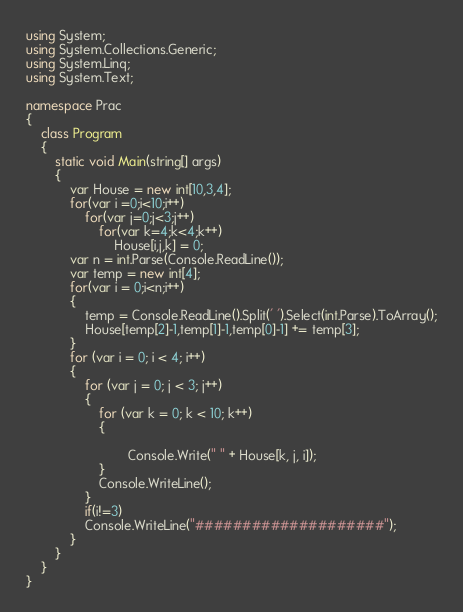Convert code to text. <code><loc_0><loc_0><loc_500><loc_500><_C#_>using System;
using System.Collections.Generic;
using System.Linq;
using System.Text;

namespace Prac
{
    class Program
    {
        static void Main(string[] args)
        {
            var House = new int[10,3,4];
            for(var i =0;i<10;i++)
                for(var j=0;j<3;j++)
                    for(var k=4;k<4;k++)
                        House[i,j,k] = 0;
            var n = int.Parse(Console.ReadLine());
            var temp = new int[4];
            for(var i = 0;i<n;i++)
            {
                temp = Console.ReadLine().Split(' ').Select(int.Parse).ToArray();
                House[temp[2]-1,temp[1]-1,temp[0]-1] += temp[3];
            }
            for (var i = 0; i < 4; i++)
            {
                for (var j = 0; j < 3; j++)
                {
                    for (var k = 0; k < 10; k++)
                    {

                            Console.Write(" " + House[k, j, i]);
                    }
                    Console.WriteLine();
                }
                if(i!=3)
                Console.WriteLine("####################");
            }
        }
    }
}</code> 